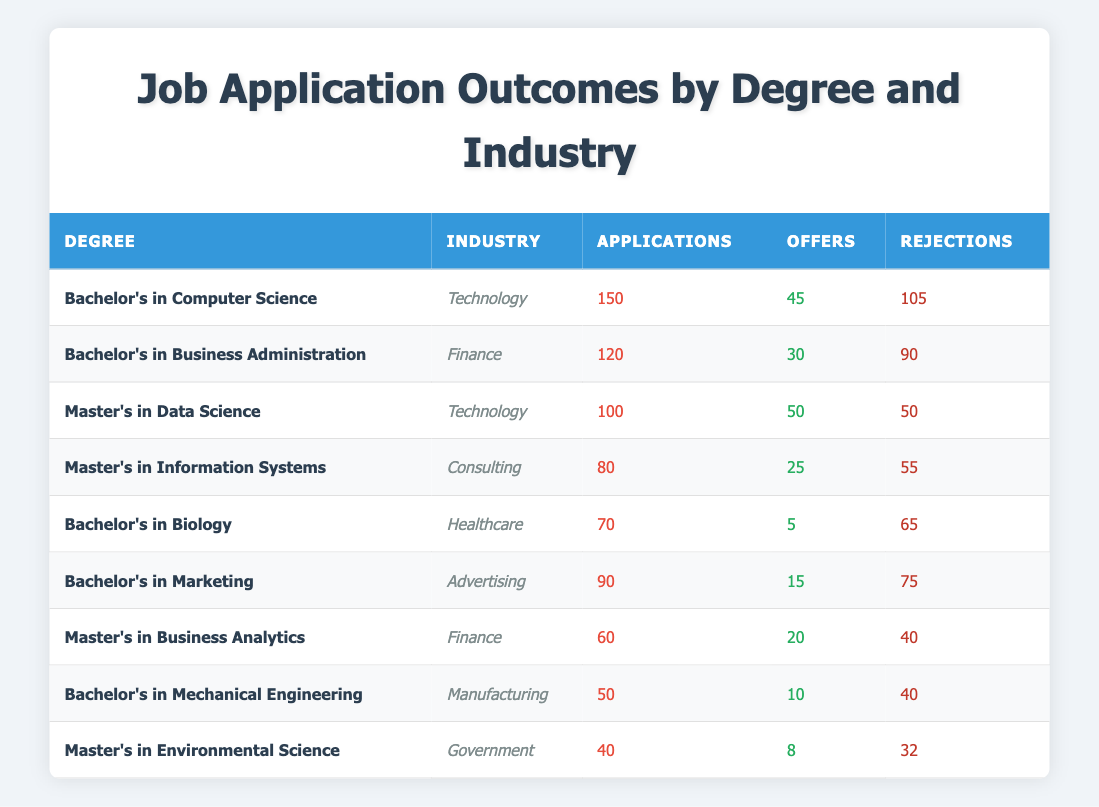What is the total number of applications for the Master's in Data Science? In the table, we look for the row corresponding to "Master's in Data Science." The number of applications listed there is 100.
Answer: 100 Which degree in the Healthcare industry received the most rejections? In the Healthcare industry, only "Bachelor's in Biology" is listed. It received 65 rejections, which is the only value we have in this category.
Answer: Bachelor's in Biology How many more offers were made for the Bachelor's in Computer Science than for the Bachelor's in Marketing? From the table, we see that the Bachelor's in Computer Science received 45 offers and Bachelor's in Marketing received 15 offers. To find the difference, we subtract: 45 - 15 = 30.
Answer: 30 What percentage of applications in the Finance industry resulted in offers? In the Finance industry, we have "Bachelor's in Business Administration" with 120 applications (30 offers) and "Master's in Business Analytics" with 60 applications (20 offers), totaling 180 applications (50 offers). To find the percentage, we calculate: (50 offers / 180 applications) * 100 = 27.78%.
Answer: 27.78% Did any degree in the Manufacturing industry have more offers than rejections? The Bachelor's in Mechanical Engineering in the Manufacturing industry had 10 offers and 40 rejections. Since 10 is less than 40, the answer is no.
Answer: No What is the average number of offers across all degrees listed? To calculate the average, we first sum the number of offers for all degrees: 45 + 30 + 50 + 25 + 5 + 15 + 20 + 10 + 8 = 208. There are 9 degrees, so we divide: 208 / 9 = 23.11, rounded to two decimal places gives us an average of approximately 23.11.
Answer: 23.11 Which industry had the least number of applications? From the table, we identify the applications: Technology (150), Finance (120), Consulting (80), Healthcare (70), Advertising (90), Manufacturing (50), Government (40). The least number of applications is in the Government industry with 40 applications.
Answer: Government Is it true that the Master’s in Environmental Science had more offers than the Bachelor’s in Biology? The Master's in Environmental Science had 8 offers, while the Bachelor's in Biology had only 5 offers. Since 8 is more than 5, the statement is true.
Answer: Yes What is the total number of rejections across all degrees? To find the total rejections, we sum the rejections for all degrees: 105 + 90 + 50 + 55 + 65 + 75 + 40 + 40 + 32 = 542. Therefore, the total number of rejections is 542.
Answer: 542 How many degrees achieved a rejection rate of more than 60%? We calculate the rejection rate for each degree. For each degree, we need to divide the number of rejections by the number of applications and check if it exceeds 60%. Only the Bachelor's in Biology (65/70) and the Bachelor's in Marketing (75/90) exceed 60%. Thus, 2 degrees meet this criterion.
Answer: 2 